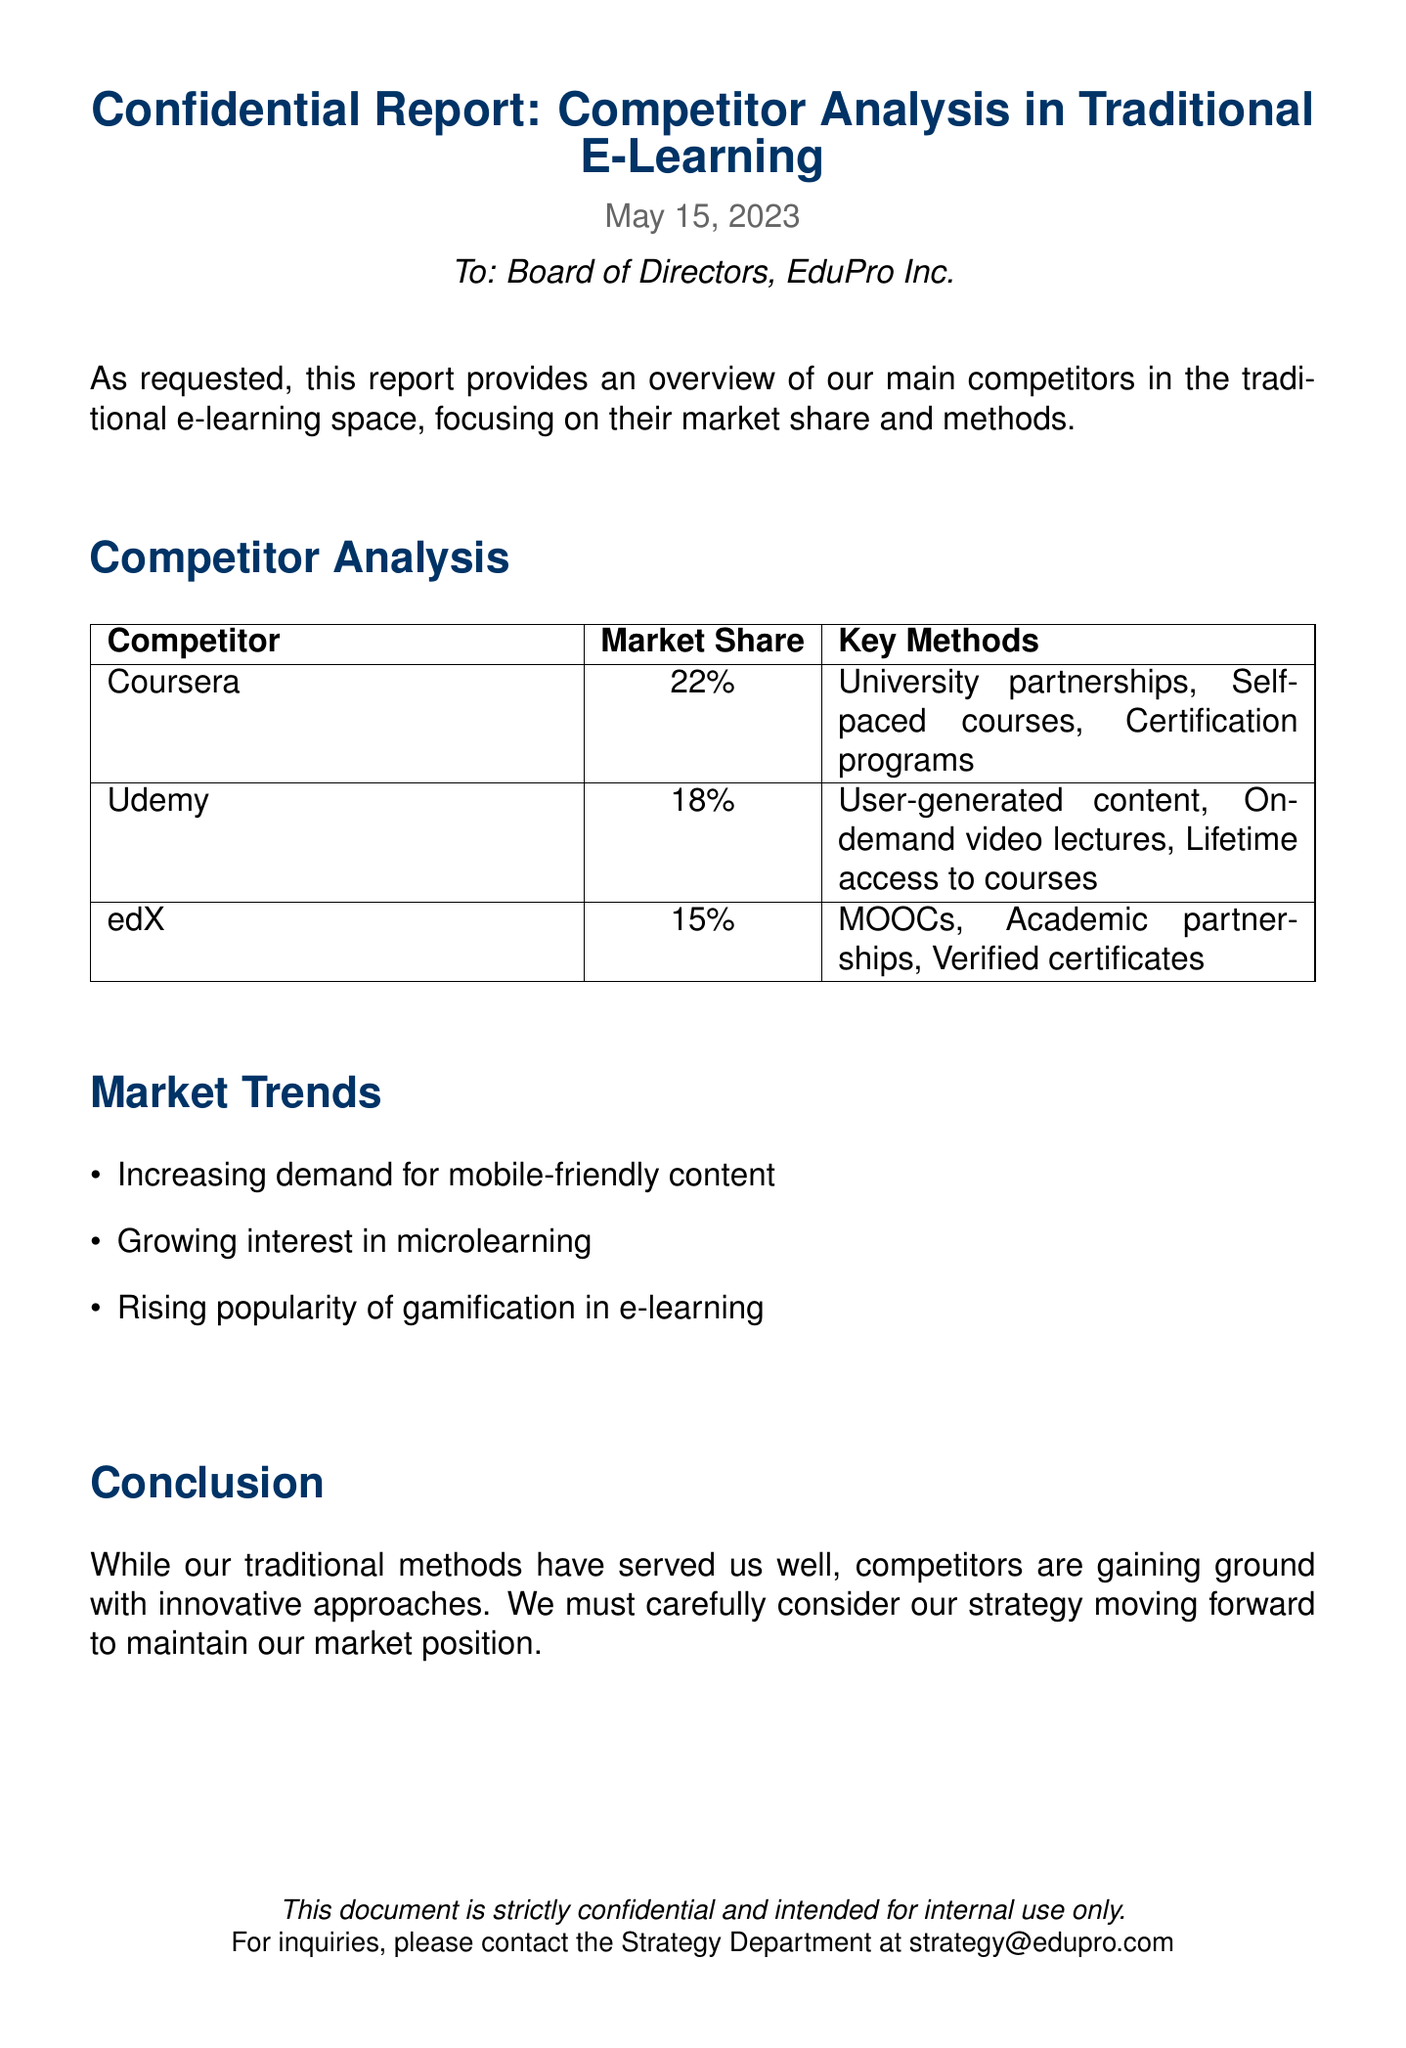What is the date of the report? The date of the report is clearly stated in the document, which is May 15, 2023.
Answer: May 15, 2023 What is Coursera's market share? The document lists Coursera's market share as one of the competitor statistics provided, which is 22%.
Answer: 22% What key methods does Udemy use? The document outlines key methods utilized by Udemy, including user-generated content, on-demand video lectures, and lifetime access to courses.
Answer: User-generated content, on-demand video lectures, lifetime access to courses What trend is mentioned related to e-learning? The document highlights several market trends, and one of them is the increase in demand for mobile-friendly content.
Answer: Increasing demand for mobile-friendly content Which competitor has a market share of 15%? The document specifies the market share of edX, which is 15%.
Answer: edX What is the primary focus of this report? The report specifically aims to provide an overview of main competitors in the traditional e-learning space, emphasizing market share and methods.
Answer: Competitor analysis in traditional e-learning What are MOOCs associated with? The document indicates that MOOCs are a key method utilized by edX, showing their significance in this educational sector.
Answer: edX Which method is linked with growing interest in e-learning? The document mentions that microlearning is a rising interest in the e-learning space, indicating its growing relevance.
Answer: Microlearning 